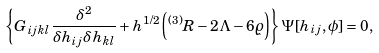Convert formula to latex. <formula><loc_0><loc_0><loc_500><loc_500>\left \{ G _ { i j k l } \frac { \delta ^ { 2 } } { \delta h _ { i j } \delta h _ { k l } } + h ^ { 1 / 2 } \left ( { ^ { ( 3 ) } R } - 2 \Lambda - 6 \varrho \right ) \right \} \Psi [ h _ { i j } , \phi ] = 0 ,</formula> 